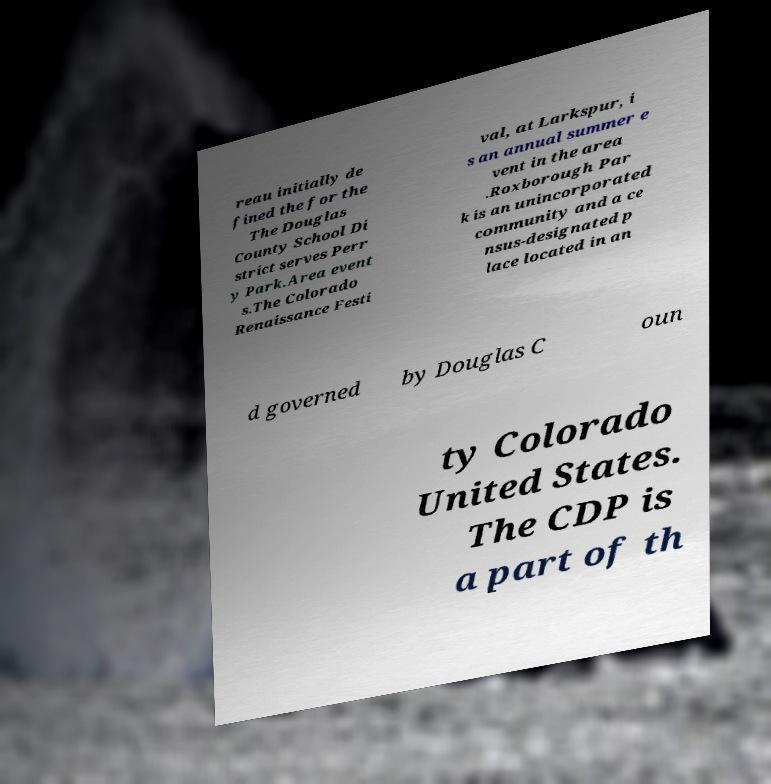I need the written content from this picture converted into text. Can you do that? reau initially de fined the for the The Douglas County School Di strict serves Perr y Park.Area event s.The Colorado Renaissance Festi val, at Larkspur, i s an annual summer e vent in the area .Roxborough Par k is an unincorporated community and a ce nsus-designated p lace located in an d governed by Douglas C oun ty Colorado United States. The CDP is a part of th 